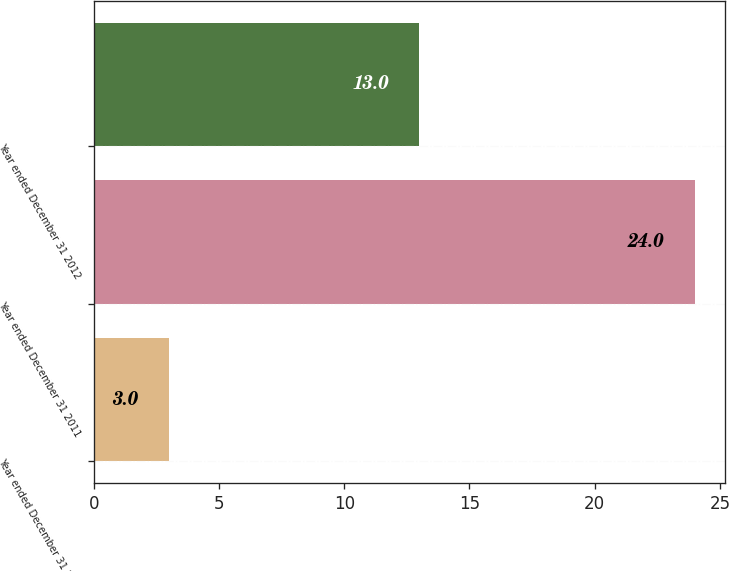Convert chart to OTSL. <chart><loc_0><loc_0><loc_500><loc_500><bar_chart><fcel>Year ended December 31 2010<fcel>Year ended December 31 2011<fcel>Year ended December 31 2012<nl><fcel>3<fcel>24<fcel>13<nl></chart> 